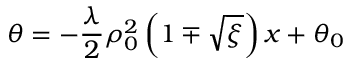Convert formula to latex. <formula><loc_0><loc_0><loc_500><loc_500>\theta = - \frac { \lambda } { 2 } \rho _ { 0 } ^ { 2 } \left ( 1 \mp \sqrt { \xi } \right ) x + \theta _ { 0 }</formula> 